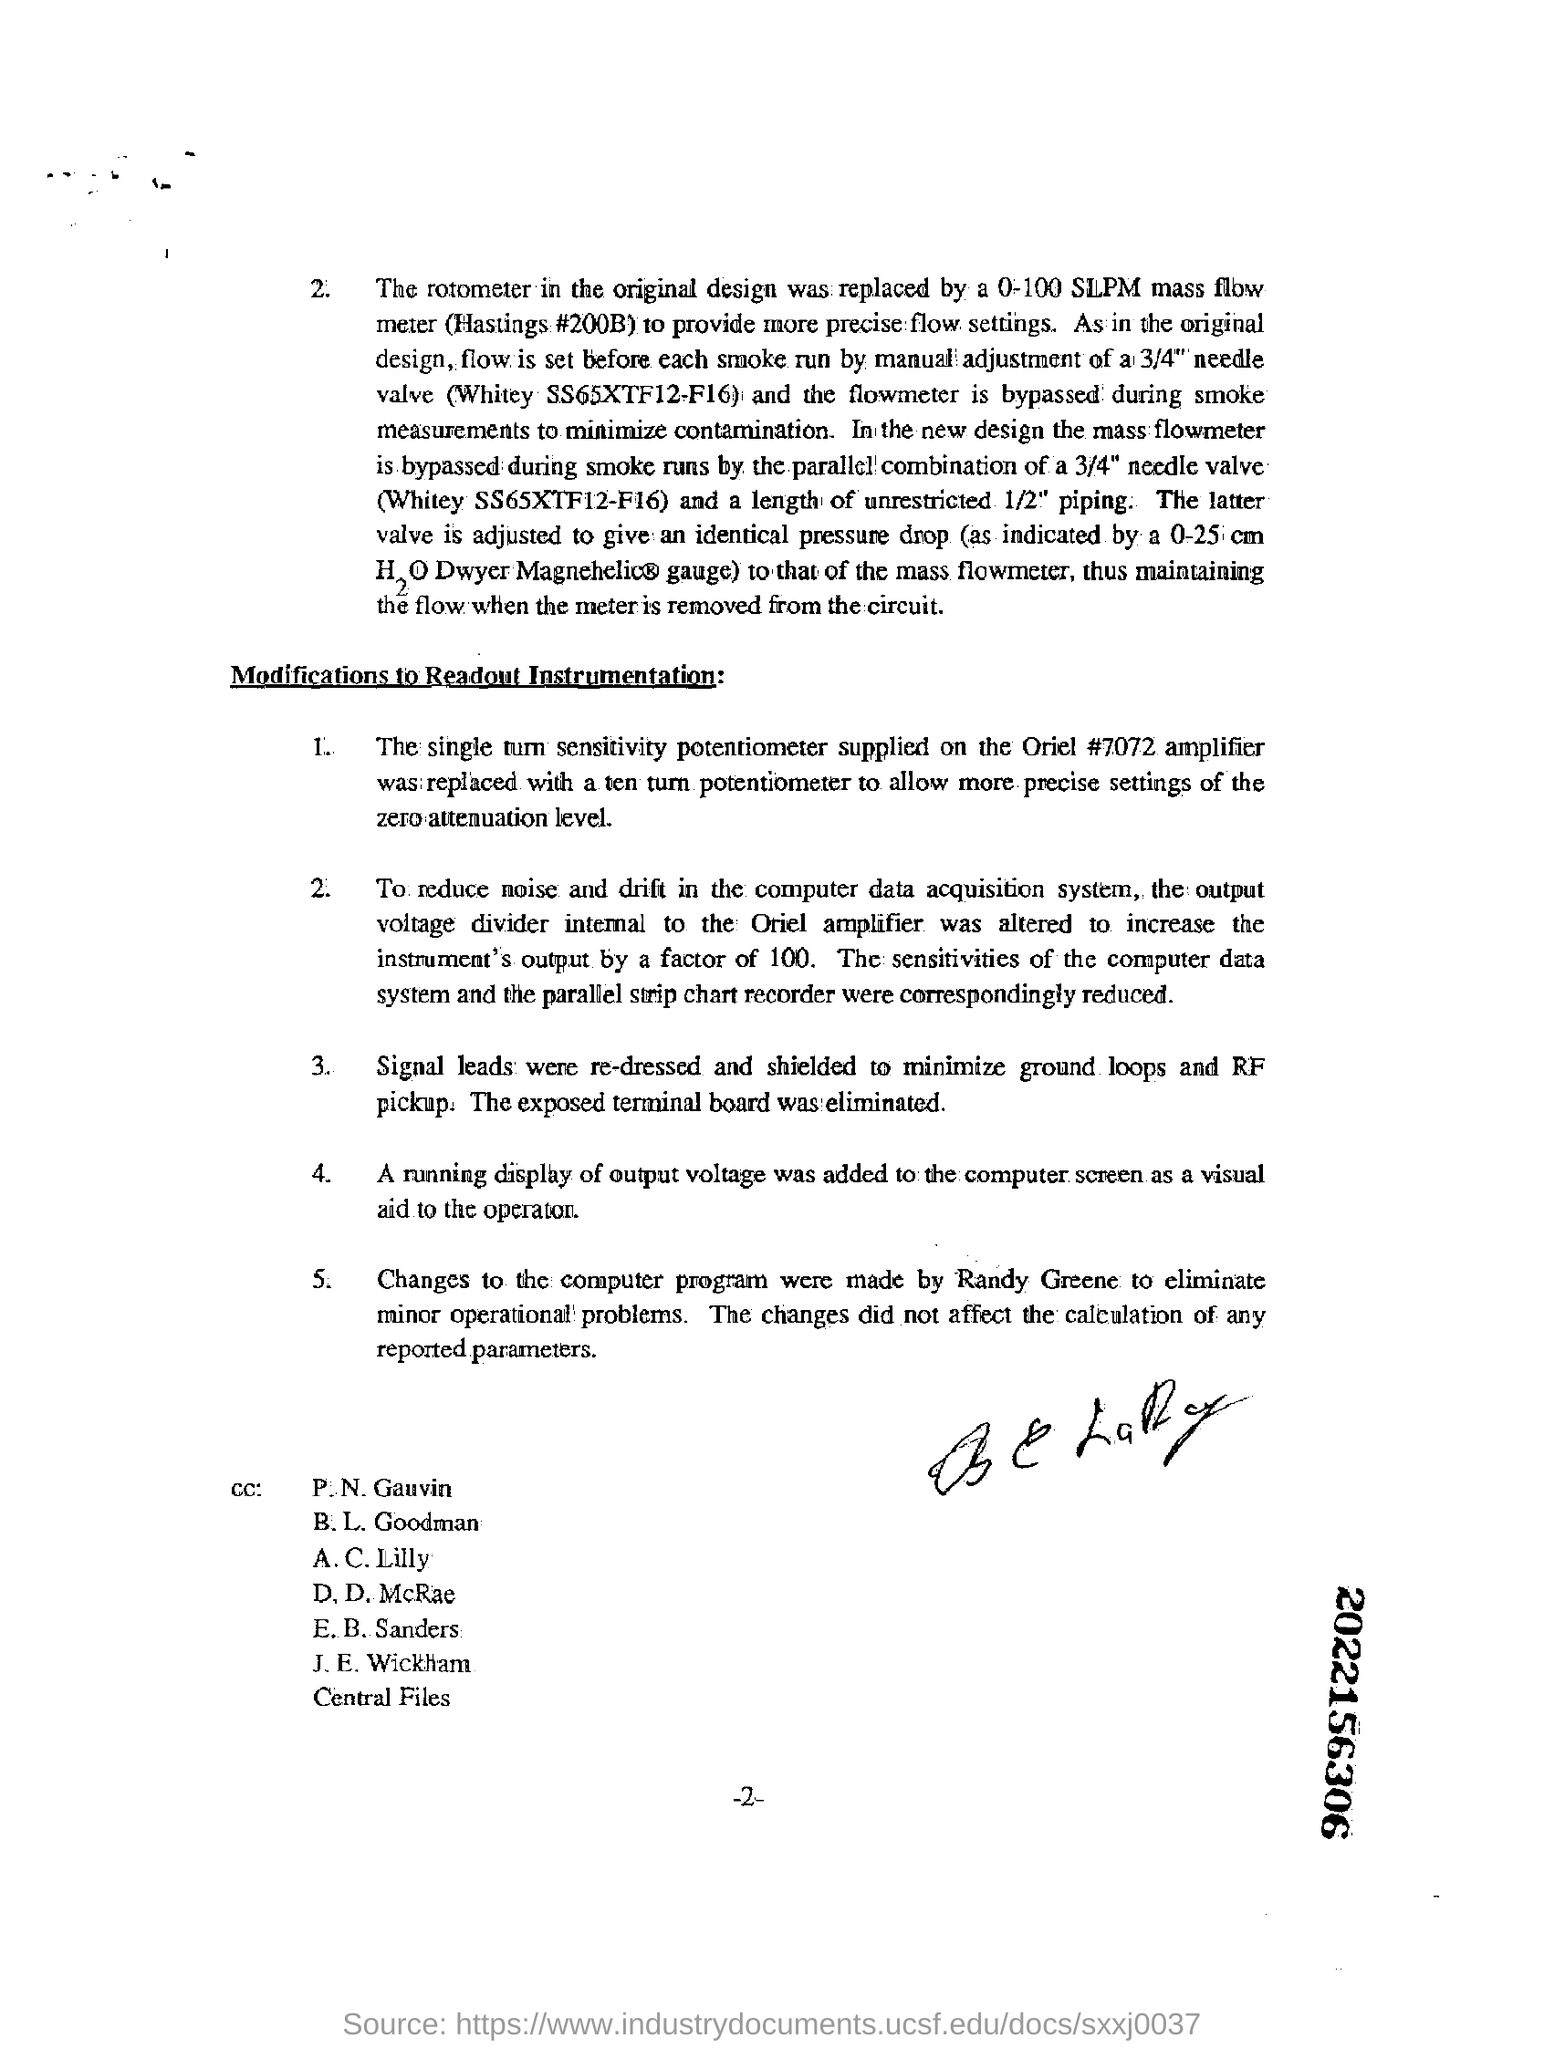Outline some significant characteristics in this image. There are five points in modifications to readout instrumentation. 